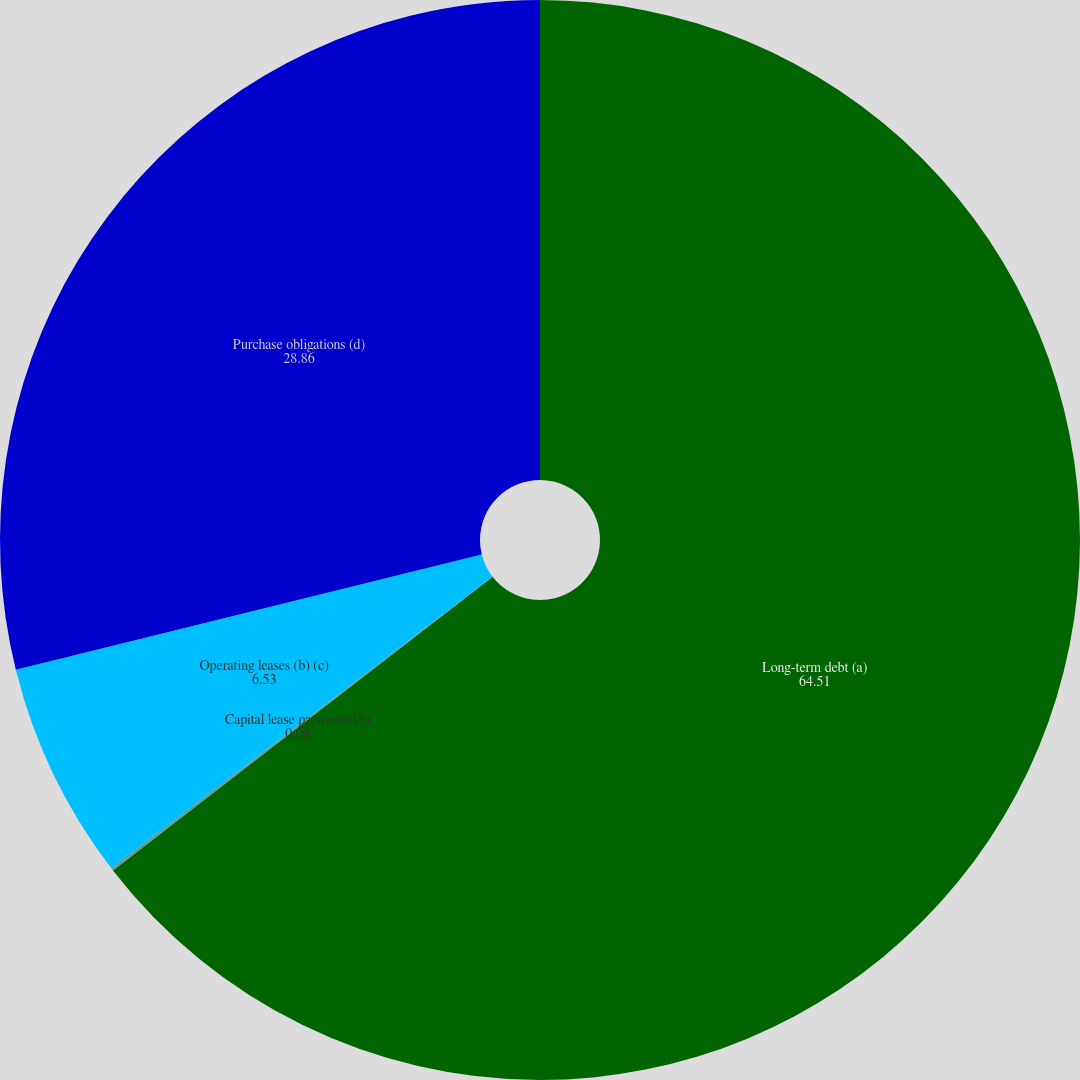<chart> <loc_0><loc_0><loc_500><loc_500><pie_chart><fcel>Long-term debt (a)<fcel>Capital lease payments (b)<fcel>Operating leases (b) (c)<fcel>Purchase obligations (d)<nl><fcel>64.51%<fcel>0.09%<fcel>6.53%<fcel>28.86%<nl></chart> 